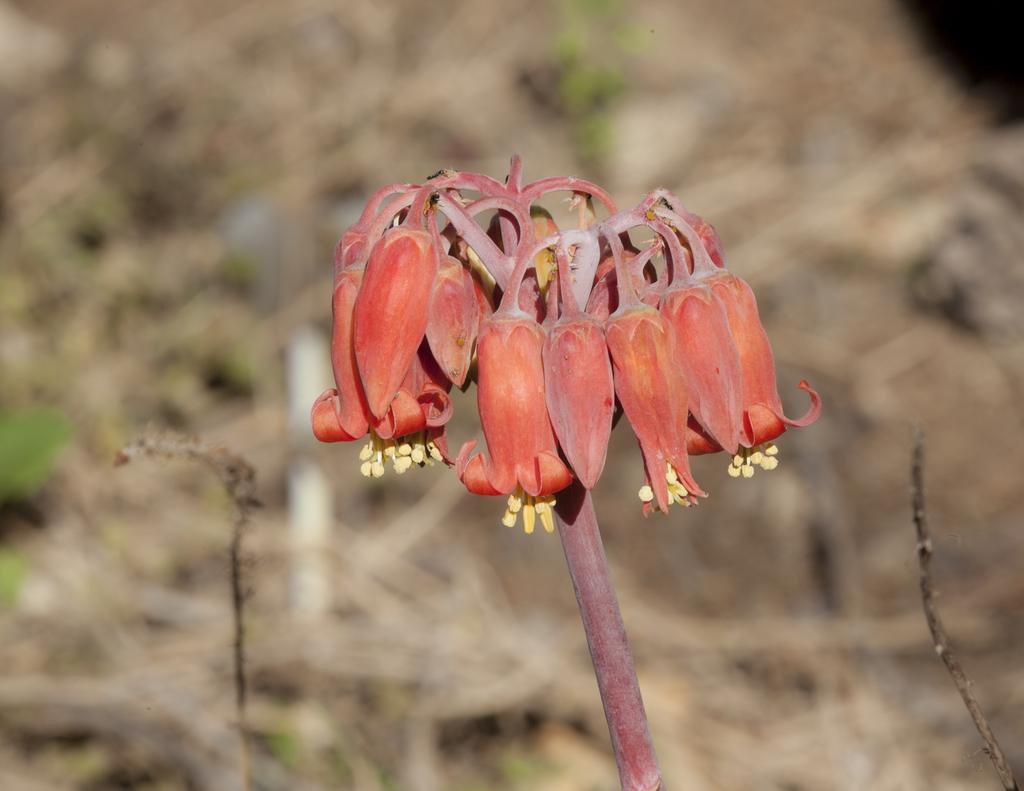Describe this image in one or two sentences. In the image we can see a flower and this is a stem of the flower and the background is blurred. 